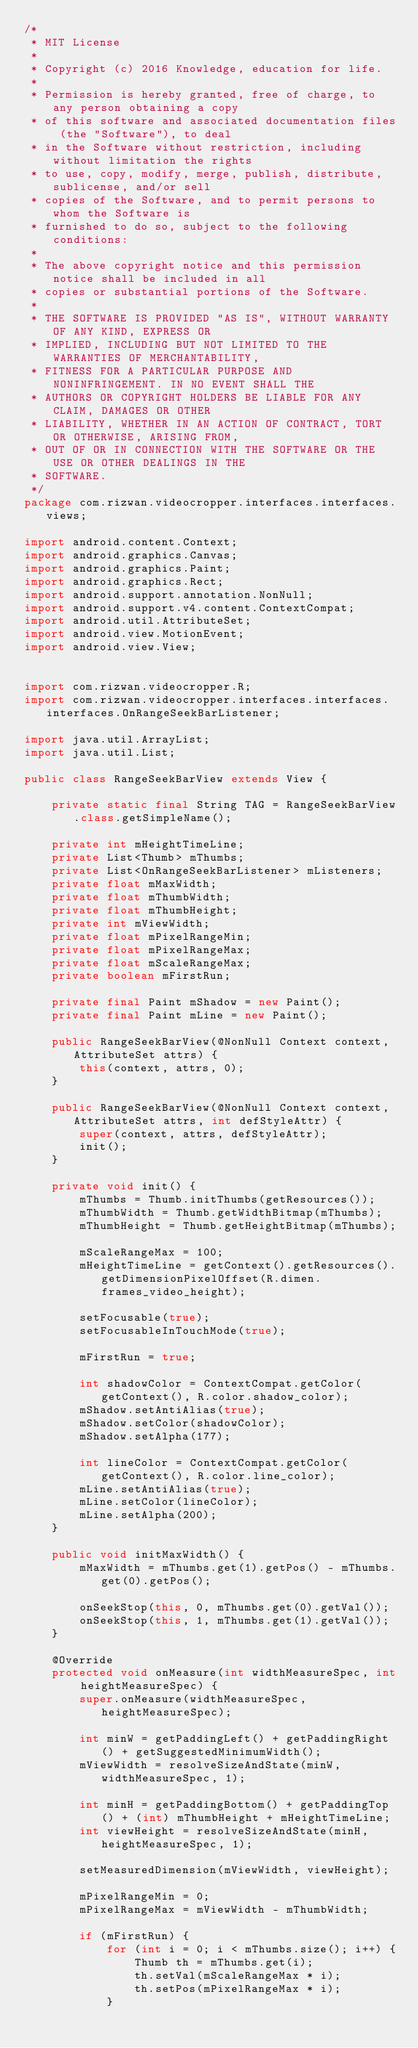<code> <loc_0><loc_0><loc_500><loc_500><_Java_>/*
 * MIT License
 *
 * Copyright (c) 2016 Knowledge, education for life.
 *
 * Permission is hereby granted, free of charge, to any person obtaining a copy
 * of this software and associated documentation files (the "Software"), to deal
 * in the Software without restriction, including without limitation the rights
 * to use, copy, modify, merge, publish, distribute, sublicense, and/or sell
 * copies of the Software, and to permit persons to whom the Software is
 * furnished to do so, subject to the following conditions:
 *
 * The above copyright notice and this permission notice shall be included in all
 * copies or substantial portions of the Software.
 *
 * THE SOFTWARE IS PROVIDED "AS IS", WITHOUT WARRANTY OF ANY KIND, EXPRESS OR
 * IMPLIED, INCLUDING BUT NOT LIMITED TO THE WARRANTIES OF MERCHANTABILITY,
 * FITNESS FOR A PARTICULAR PURPOSE AND NONINFRINGEMENT. IN NO EVENT SHALL THE
 * AUTHORS OR COPYRIGHT HOLDERS BE LIABLE FOR ANY CLAIM, DAMAGES OR OTHER
 * LIABILITY, WHETHER IN AN ACTION OF CONTRACT, TORT OR OTHERWISE, ARISING FROM,
 * OUT OF OR IN CONNECTION WITH THE SOFTWARE OR THE USE OR OTHER DEALINGS IN THE
 * SOFTWARE.
 */
package com.rizwan.videocropper.interfaces.interfaces.views;

import android.content.Context;
import android.graphics.Canvas;
import android.graphics.Paint;
import android.graphics.Rect;
import android.support.annotation.NonNull;
import android.support.v4.content.ContextCompat;
import android.util.AttributeSet;
import android.view.MotionEvent;
import android.view.View;


import com.rizwan.videocropper.R;
import com.rizwan.videocropper.interfaces.interfaces.interfaces.OnRangeSeekBarListener;

import java.util.ArrayList;
import java.util.List;

public class RangeSeekBarView extends View {

    private static final String TAG = RangeSeekBarView.class.getSimpleName();

    private int mHeightTimeLine;
    private List<Thumb> mThumbs;
    private List<OnRangeSeekBarListener> mListeners;
    private float mMaxWidth;
    private float mThumbWidth;
    private float mThumbHeight;
    private int mViewWidth;
    private float mPixelRangeMin;
    private float mPixelRangeMax;
    private float mScaleRangeMax;
    private boolean mFirstRun;

    private final Paint mShadow = new Paint();
    private final Paint mLine = new Paint();

    public RangeSeekBarView(@NonNull Context context, AttributeSet attrs) {
        this(context, attrs, 0);
    }

    public RangeSeekBarView(@NonNull Context context, AttributeSet attrs, int defStyleAttr) {
        super(context, attrs, defStyleAttr);
        init();
    }

    private void init() {
        mThumbs = Thumb.initThumbs(getResources());
        mThumbWidth = Thumb.getWidthBitmap(mThumbs);
        mThumbHeight = Thumb.getHeightBitmap(mThumbs);

        mScaleRangeMax = 100;
        mHeightTimeLine = getContext().getResources().getDimensionPixelOffset(R.dimen.frames_video_height);

        setFocusable(true);
        setFocusableInTouchMode(true);

        mFirstRun = true;

        int shadowColor = ContextCompat.getColor(getContext(), R.color.shadow_color);
        mShadow.setAntiAlias(true);
        mShadow.setColor(shadowColor);
        mShadow.setAlpha(177);

        int lineColor = ContextCompat.getColor(getContext(), R.color.line_color);
        mLine.setAntiAlias(true);
        mLine.setColor(lineColor);
        mLine.setAlpha(200);
    }

    public void initMaxWidth() {
        mMaxWidth = mThumbs.get(1).getPos() - mThumbs.get(0).getPos();

        onSeekStop(this, 0, mThumbs.get(0).getVal());
        onSeekStop(this, 1, mThumbs.get(1).getVal());
    }

    @Override
    protected void onMeasure(int widthMeasureSpec, int heightMeasureSpec) {
        super.onMeasure(widthMeasureSpec, heightMeasureSpec);

        int minW = getPaddingLeft() + getPaddingRight() + getSuggestedMinimumWidth();
        mViewWidth = resolveSizeAndState(minW, widthMeasureSpec, 1);

        int minH = getPaddingBottom() + getPaddingTop() + (int) mThumbHeight + mHeightTimeLine;
        int viewHeight = resolveSizeAndState(minH, heightMeasureSpec, 1);

        setMeasuredDimension(mViewWidth, viewHeight);

        mPixelRangeMin = 0;
        mPixelRangeMax = mViewWidth - mThumbWidth;

        if (mFirstRun) {
            for (int i = 0; i < mThumbs.size(); i++) {
                Thumb th = mThumbs.get(i);
                th.setVal(mScaleRangeMax * i);
                th.setPos(mPixelRangeMax * i);
            }</code> 